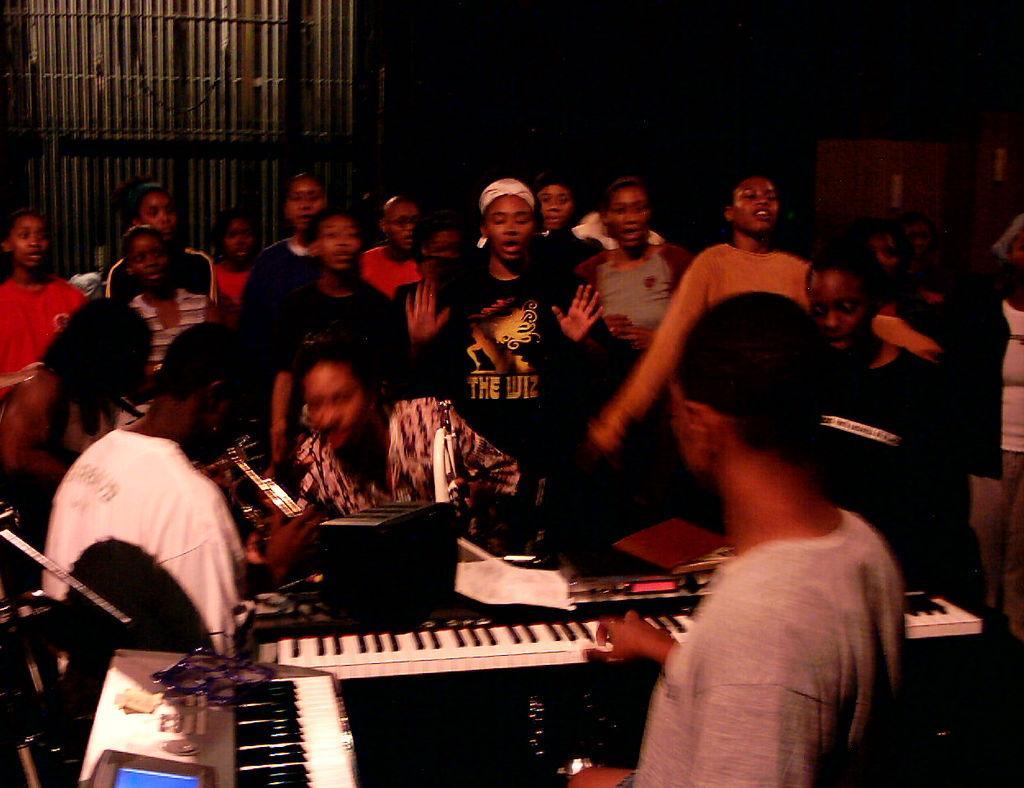Can you describe this image briefly? As we can see in the image there are few people sitting and few of them are standing and in the front there are blue and white color musical keyboards. 